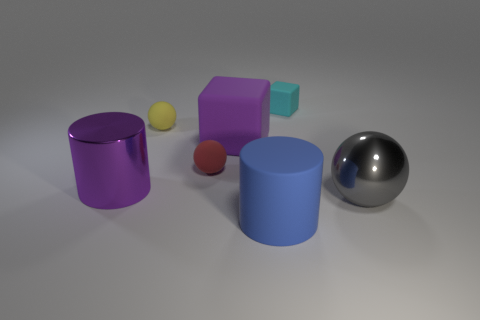Add 2 small cyan rubber cylinders. How many objects exist? 9 Subtract all cubes. How many objects are left? 5 Add 2 purple matte blocks. How many purple matte blocks are left? 3 Add 3 tiny red spheres. How many tiny red spheres exist? 4 Subtract 0 green cylinders. How many objects are left? 7 Subtract all big blue objects. Subtract all big blue rubber things. How many objects are left? 5 